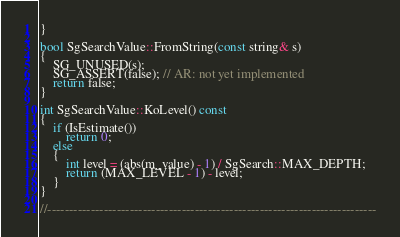Convert code to text. <code><loc_0><loc_0><loc_500><loc_500><_C++_>}

bool SgSearchValue::FromString(const string& s)
{
    SG_UNUSED(s);
    SG_ASSERT(false); // AR: not yet implemented
    return false;
}

int SgSearchValue::KoLevel() const
{
    if (IsEstimate())
        return 0;
    else
    {
        int level = (abs(m_value) - 1) / SgSearch::MAX_DEPTH;
        return (MAX_LEVEL - 1) - level;
    }
}

//----------------------------------------------------------------------------

</code> 